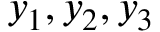<formula> <loc_0><loc_0><loc_500><loc_500>y _ { 1 } , y _ { 2 } , y _ { 3 }</formula> 